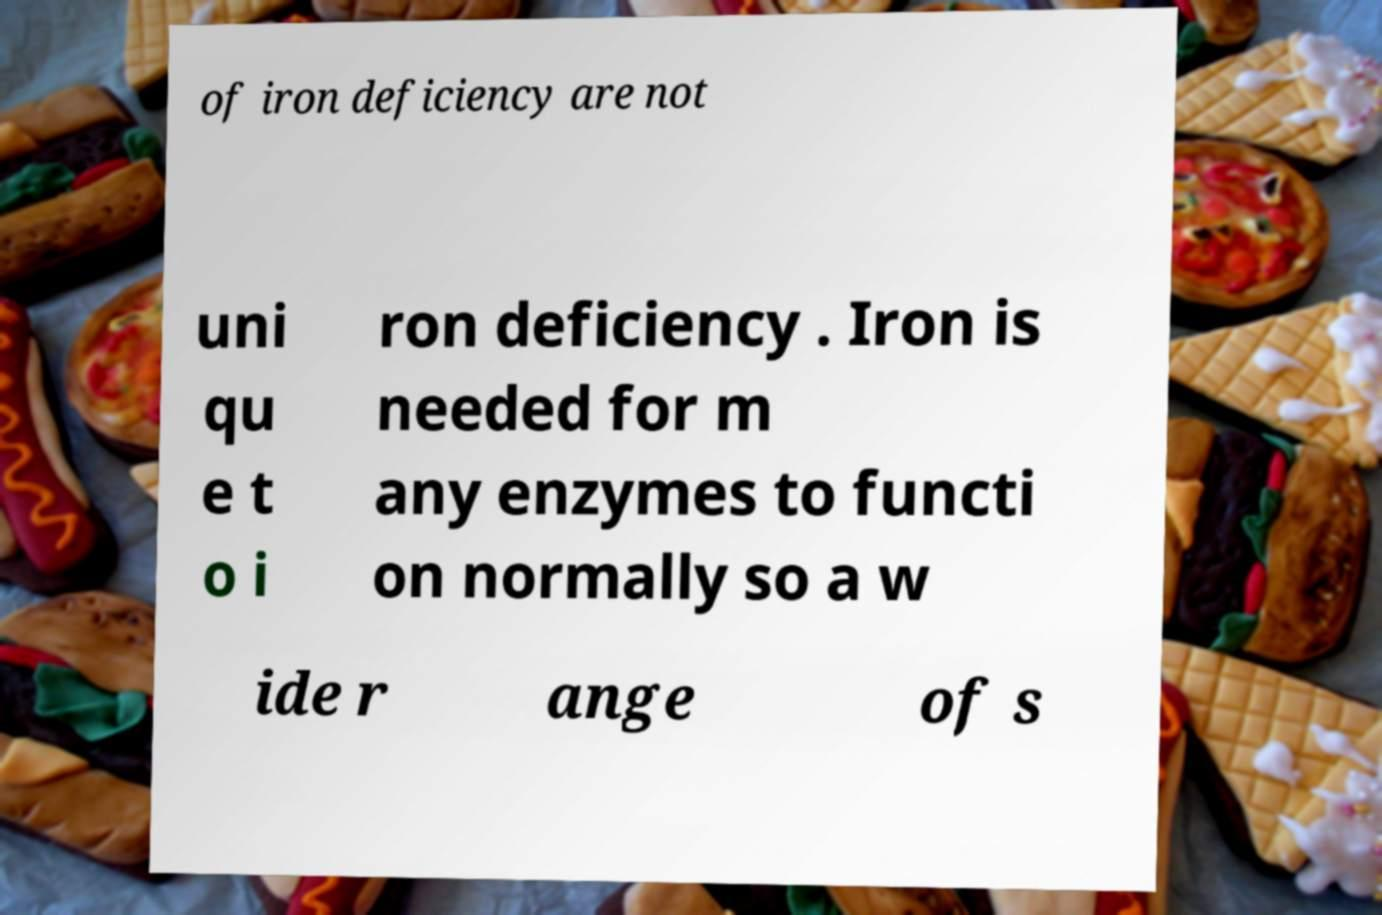I need the written content from this picture converted into text. Can you do that? of iron deficiency are not uni qu e t o i ron deficiency . Iron is needed for m any enzymes to functi on normally so a w ide r ange of s 